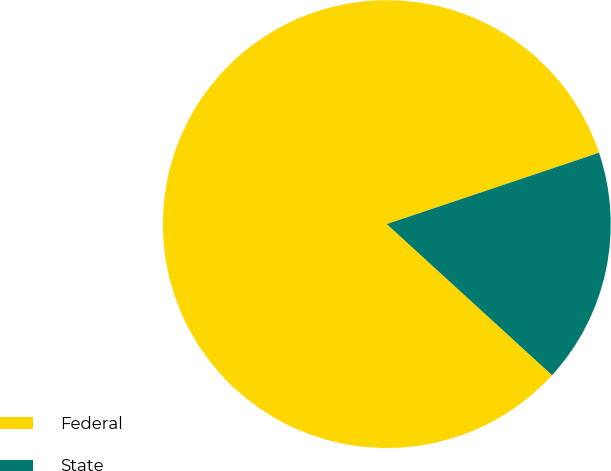Convert chart. <chart><loc_0><loc_0><loc_500><loc_500><pie_chart><fcel>Federal<fcel>State<nl><fcel>83.05%<fcel>16.95%<nl></chart> 